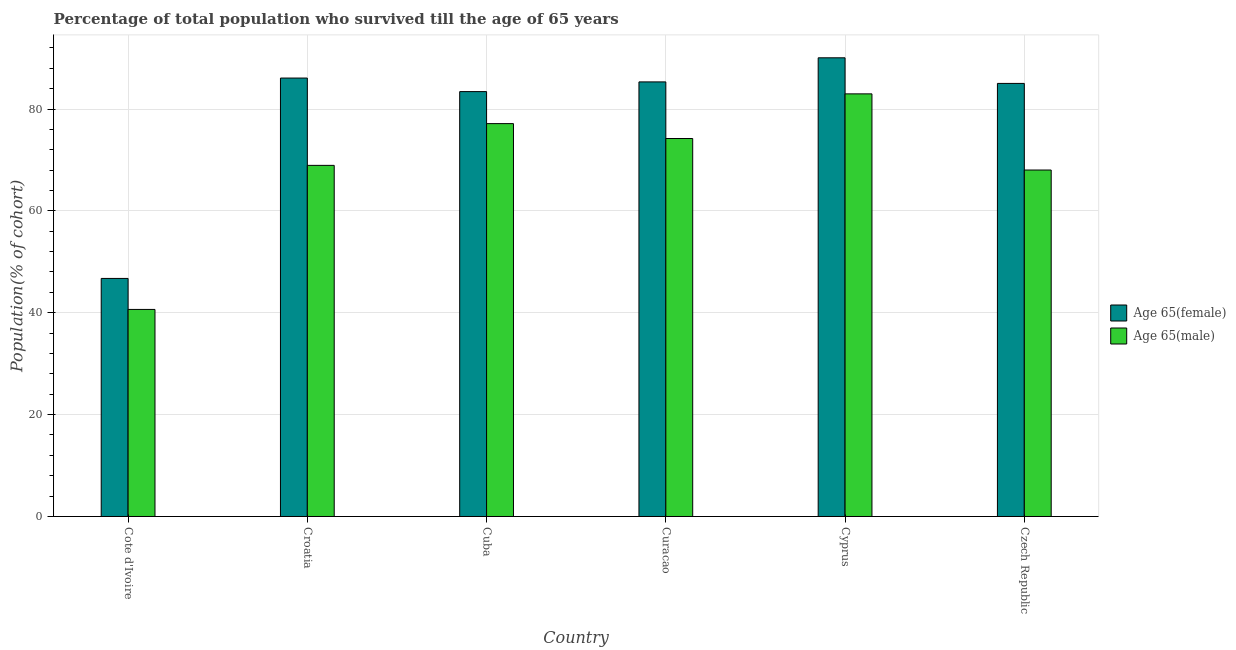How many different coloured bars are there?
Keep it short and to the point. 2. Are the number of bars on each tick of the X-axis equal?
Make the answer very short. Yes. How many bars are there on the 4th tick from the right?
Make the answer very short. 2. What is the label of the 4th group of bars from the left?
Make the answer very short. Curacao. What is the percentage of female population who survived till age of 65 in Curacao?
Offer a very short reply. 85.32. Across all countries, what is the maximum percentage of female population who survived till age of 65?
Give a very brief answer. 90.05. Across all countries, what is the minimum percentage of male population who survived till age of 65?
Your answer should be very brief. 40.65. In which country was the percentage of female population who survived till age of 65 maximum?
Make the answer very short. Cyprus. In which country was the percentage of female population who survived till age of 65 minimum?
Your answer should be compact. Cote d'Ivoire. What is the total percentage of male population who survived till age of 65 in the graph?
Make the answer very short. 411.92. What is the difference between the percentage of male population who survived till age of 65 in Croatia and that in Czech Republic?
Your answer should be compact. 0.91. What is the difference between the percentage of male population who survived till age of 65 in Cuba and the percentage of female population who survived till age of 65 in Cote d'Ivoire?
Make the answer very short. 30.39. What is the average percentage of male population who survived till age of 65 per country?
Your answer should be compact. 68.65. What is the difference between the percentage of male population who survived till age of 65 and percentage of female population who survived till age of 65 in Cuba?
Offer a terse response. -6.28. In how many countries, is the percentage of female population who survived till age of 65 greater than 44 %?
Your answer should be very brief. 6. What is the ratio of the percentage of male population who survived till age of 65 in Cuba to that in Czech Republic?
Give a very brief answer. 1.13. What is the difference between the highest and the second highest percentage of male population who survived till age of 65?
Make the answer very short. 5.84. What is the difference between the highest and the lowest percentage of male population who survived till age of 65?
Your answer should be compact. 42.32. Is the sum of the percentage of male population who survived till age of 65 in Curacao and Cyprus greater than the maximum percentage of female population who survived till age of 65 across all countries?
Your answer should be very brief. Yes. What does the 2nd bar from the left in Croatia represents?
Offer a very short reply. Age 65(male). What does the 2nd bar from the right in Cuba represents?
Your answer should be compact. Age 65(female). Are all the bars in the graph horizontal?
Make the answer very short. No. How many countries are there in the graph?
Your answer should be compact. 6. What is the difference between two consecutive major ticks on the Y-axis?
Offer a very short reply. 20. Does the graph contain grids?
Your response must be concise. Yes. How are the legend labels stacked?
Give a very brief answer. Vertical. What is the title of the graph?
Make the answer very short. Percentage of total population who survived till the age of 65 years. Does "Male" appear as one of the legend labels in the graph?
Provide a short and direct response. No. What is the label or title of the Y-axis?
Offer a terse response. Population(% of cohort). What is the Population(% of cohort) in Age 65(female) in Cote d'Ivoire?
Ensure brevity in your answer.  46.74. What is the Population(% of cohort) in Age 65(male) in Cote d'Ivoire?
Provide a succinct answer. 40.65. What is the Population(% of cohort) in Age 65(female) in Croatia?
Provide a short and direct response. 86.08. What is the Population(% of cohort) in Age 65(male) in Croatia?
Provide a succinct answer. 68.94. What is the Population(% of cohort) of Age 65(female) in Cuba?
Your answer should be very brief. 83.42. What is the Population(% of cohort) of Age 65(male) in Cuba?
Offer a terse response. 77.13. What is the Population(% of cohort) in Age 65(female) in Curacao?
Your answer should be compact. 85.32. What is the Population(% of cohort) of Age 65(male) in Curacao?
Ensure brevity in your answer.  74.21. What is the Population(% of cohort) of Age 65(female) in Cyprus?
Your answer should be compact. 90.05. What is the Population(% of cohort) of Age 65(male) in Cyprus?
Provide a succinct answer. 82.97. What is the Population(% of cohort) in Age 65(female) in Czech Republic?
Make the answer very short. 85.02. What is the Population(% of cohort) in Age 65(male) in Czech Republic?
Make the answer very short. 68.02. Across all countries, what is the maximum Population(% of cohort) of Age 65(female)?
Ensure brevity in your answer.  90.05. Across all countries, what is the maximum Population(% of cohort) in Age 65(male)?
Your answer should be very brief. 82.97. Across all countries, what is the minimum Population(% of cohort) of Age 65(female)?
Keep it short and to the point. 46.74. Across all countries, what is the minimum Population(% of cohort) in Age 65(male)?
Offer a terse response. 40.65. What is the total Population(% of cohort) of Age 65(female) in the graph?
Your answer should be compact. 476.63. What is the total Population(% of cohort) of Age 65(male) in the graph?
Keep it short and to the point. 411.92. What is the difference between the Population(% of cohort) of Age 65(female) in Cote d'Ivoire and that in Croatia?
Make the answer very short. -39.34. What is the difference between the Population(% of cohort) in Age 65(male) in Cote d'Ivoire and that in Croatia?
Your answer should be compact. -28.29. What is the difference between the Population(% of cohort) in Age 65(female) in Cote d'Ivoire and that in Cuba?
Your answer should be very brief. -36.68. What is the difference between the Population(% of cohort) in Age 65(male) in Cote d'Ivoire and that in Cuba?
Ensure brevity in your answer.  -36.48. What is the difference between the Population(% of cohort) in Age 65(female) in Cote d'Ivoire and that in Curacao?
Make the answer very short. -38.58. What is the difference between the Population(% of cohort) of Age 65(male) in Cote d'Ivoire and that in Curacao?
Your answer should be compact. -33.56. What is the difference between the Population(% of cohort) of Age 65(female) in Cote d'Ivoire and that in Cyprus?
Your answer should be compact. -43.31. What is the difference between the Population(% of cohort) in Age 65(male) in Cote d'Ivoire and that in Cyprus?
Keep it short and to the point. -42.32. What is the difference between the Population(% of cohort) in Age 65(female) in Cote d'Ivoire and that in Czech Republic?
Offer a very short reply. -38.28. What is the difference between the Population(% of cohort) in Age 65(male) in Cote d'Ivoire and that in Czech Republic?
Give a very brief answer. -27.37. What is the difference between the Population(% of cohort) of Age 65(female) in Croatia and that in Cuba?
Offer a terse response. 2.66. What is the difference between the Population(% of cohort) in Age 65(male) in Croatia and that in Cuba?
Provide a succinct answer. -8.2. What is the difference between the Population(% of cohort) in Age 65(female) in Croatia and that in Curacao?
Ensure brevity in your answer.  0.76. What is the difference between the Population(% of cohort) of Age 65(male) in Croatia and that in Curacao?
Provide a short and direct response. -5.27. What is the difference between the Population(% of cohort) in Age 65(female) in Croatia and that in Cyprus?
Your response must be concise. -3.97. What is the difference between the Population(% of cohort) in Age 65(male) in Croatia and that in Cyprus?
Keep it short and to the point. -14.04. What is the difference between the Population(% of cohort) of Age 65(female) in Croatia and that in Czech Republic?
Offer a terse response. 1.05. What is the difference between the Population(% of cohort) of Age 65(male) in Croatia and that in Czech Republic?
Provide a short and direct response. 0.91. What is the difference between the Population(% of cohort) of Age 65(female) in Cuba and that in Curacao?
Keep it short and to the point. -1.91. What is the difference between the Population(% of cohort) in Age 65(male) in Cuba and that in Curacao?
Give a very brief answer. 2.93. What is the difference between the Population(% of cohort) of Age 65(female) in Cuba and that in Cyprus?
Your answer should be compact. -6.64. What is the difference between the Population(% of cohort) in Age 65(male) in Cuba and that in Cyprus?
Provide a succinct answer. -5.84. What is the difference between the Population(% of cohort) of Age 65(female) in Cuba and that in Czech Republic?
Provide a succinct answer. -1.61. What is the difference between the Population(% of cohort) of Age 65(male) in Cuba and that in Czech Republic?
Offer a terse response. 9.11. What is the difference between the Population(% of cohort) of Age 65(female) in Curacao and that in Cyprus?
Make the answer very short. -4.73. What is the difference between the Population(% of cohort) of Age 65(male) in Curacao and that in Cyprus?
Your answer should be very brief. -8.76. What is the difference between the Population(% of cohort) in Age 65(female) in Curacao and that in Czech Republic?
Provide a short and direct response. 0.3. What is the difference between the Population(% of cohort) in Age 65(male) in Curacao and that in Czech Republic?
Offer a terse response. 6.19. What is the difference between the Population(% of cohort) of Age 65(female) in Cyprus and that in Czech Republic?
Offer a terse response. 5.03. What is the difference between the Population(% of cohort) of Age 65(male) in Cyprus and that in Czech Republic?
Ensure brevity in your answer.  14.95. What is the difference between the Population(% of cohort) in Age 65(female) in Cote d'Ivoire and the Population(% of cohort) in Age 65(male) in Croatia?
Offer a very short reply. -22.2. What is the difference between the Population(% of cohort) in Age 65(female) in Cote d'Ivoire and the Population(% of cohort) in Age 65(male) in Cuba?
Provide a short and direct response. -30.39. What is the difference between the Population(% of cohort) of Age 65(female) in Cote d'Ivoire and the Population(% of cohort) of Age 65(male) in Curacao?
Give a very brief answer. -27.47. What is the difference between the Population(% of cohort) of Age 65(female) in Cote d'Ivoire and the Population(% of cohort) of Age 65(male) in Cyprus?
Give a very brief answer. -36.23. What is the difference between the Population(% of cohort) in Age 65(female) in Cote d'Ivoire and the Population(% of cohort) in Age 65(male) in Czech Republic?
Give a very brief answer. -21.28. What is the difference between the Population(% of cohort) of Age 65(female) in Croatia and the Population(% of cohort) of Age 65(male) in Cuba?
Ensure brevity in your answer.  8.95. What is the difference between the Population(% of cohort) of Age 65(female) in Croatia and the Population(% of cohort) of Age 65(male) in Curacao?
Make the answer very short. 11.87. What is the difference between the Population(% of cohort) in Age 65(female) in Croatia and the Population(% of cohort) in Age 65(male) in Cyprus?
Your answer should be compact. 3.11. What is the difference between the Population(% of cohort) in Age 65(female) in Croatia and the Population(% of cohort) in Age 65(male) in Czech Republic?
Make the answer very short. 18.06. What is the difference between the Population(% of cohort) in Age 65(female) in Cuba and the Population(% of cohort) in Age 65(male) in Curacao?
Your response must be concise. 9.21. What is the difference between the Population(% of cohort) of Age 65(female) in Cuba and the Population(% of cohort) of Age 65(male) in Cyprus?
Provide a succinct answer. 0.45. What is the difference between the Population(% of cohort) in Age 65(female) in Cuba and the Population(% of cohort) in Age 65(male) in Czech Republic?
Ensure brevity in your answer.  15.4. What is the difference between the Population(% of cohort) in Age 65(female) in Curacao and the Population(% of cohort) in Age 65(male) in Cyprus?
Ensure brevity in your answer.  2.35. What is the difference between the Population(% of cohort) in Age 65(female) in Curacao and the Population(% of cohort) in Age 65(male) in Czech Republic?
Provide a succinct answer. 17.3. What is the difference between the Population(% of cohort) of Age 65(female) in Cyprus and the Population(% of cohort) of Age 65(male) in Czech Republic?
Provide a short and direct response. 22.03. What is the average Population(% of cohort) of Age 65(female) per country?
Your answer should be very brief. 79.44. What is the average Population(% of cohort) of Age 65(male) per country?
Your answer should be compact. 68.65. What is the difference between the Population(% of cohort) in Age 65(female) and Population(% of cohort) in Age 65(male) in Cote d'Ivoire?
Your answer should be compact. 6.09. What is the difference between the Population(% of cohort) of Age 65(female) and Population(% of cohort) of Age 65(male) in Croatia?
Keep it short and to the point. 17.14. What is the difference between the Population(% of cohort) of Age 65(female) and Population(% of cohort) of Age 65(male) in Cuba?
Ensure brevity in your answer.  6.28. What is the difference between the Population(% of cohort) in Age 65(female) and Population(% of cohort) in Age 65(male) in Curacao?
Make the answer very short. 11.11. What is the difference between the Population(% of cohort) in Age 65(female) and Population(% of cohort) in Age 65(male) in Cyprus?
Offer a very short reply. 7.08. What is the difference between the Population(% of cohort) of Age 65(female) and Population(% of cohort) of Age 65(male) in Czech Republic?
Provide a succinct answer. 17. What is the ratio of the Population(% of cohort) of Age 65(female) in Cote d'Ivoire to that in Croatia?
Your response must be concise. 0.54. What is the ratio of the Population(% of cohort) in Age 65(male) in Cote d'Ivoire to that in Croatia?
Offer a very short reply. 0.59. What is the ratio of the Population(% of cohort) of Age 65(female) in Cote d'Ivoire to that in Cuba?
Provide a succinct answer. 0.56. What is the ratio of the Population(% of cohort) of Age 65(male) in Cote d'Ivoire to that in Cuba?
Ensure brevity in your answer.  0.53. What is the ratio of the Population(% of cohort) of Age 65(female) in Cote d'Ivoire to that in Curacao?
Offer a very short reply. 0.55. What is the ratio of the Population(% of cohort) of Age 65(male) in Cote d'Ivoire to that in Curacao?
Offer a terse response. 0.55. What is the ratio of the Population(% of cohort) of Age 65(female) in Cote d'Ivoire to that in Cyprus?
Your answer should be compact. 0.52. What is the ratio of the Population(% of cohort) of Age 65(male) in Cote d'Ivoire to that in Cyprus?
Your response must be concise. 0.49. What is the ratio of the Population(% of cohort) in Age 65(female) in Cote d'Ivoire to that in Czech Republic?
Give a very brief answer. 0.55. What is the ratio of the Population(% of cohort) in Age 65(male) in Cote d'Ivoire to that in Czech Republic?
Keep it short and to the point. 0.6. What is the ratio of the Population(% of cohort) in Age 65(female) in Croatia to that in Cuba?
Provide a succinct answer. 1.03. What is the ratio of the Population(% of cohort) of Age 65(male) in Croatia to that in Cuba?
Give a very brief answer. 0.89. What is the ratio of the Population(% of cohort) in Age 65(female) in Croatia to that in Curacao?
Offer a terse response. 1.01. What is the ratio of the Population(% of cohort) in Age 65(male) in Croatia to that in Curacao?
Ensure brevity in your answer.  0.93. What is the ratio of the Population(% of cohort) in Age 65(female) in Croatia to that in Cyprus?
Make the answer very short. 0.96. What is the ratio of the Population(% of cohort) of Age 65(male) in Croatia to that in Cyprus?
Ensure brevity in your answer.  0.83. What is the ratio of the Population(% of cohort) in Age 65(female) in Croatia to that in Czech Republic?
Your answer should be very brief. 1.01. What is the ratio of the Population(% of cohort) of Age 65(male) in Croatia to that in Czech Republic?
Offer a terse response. 1.01. What is the ratio of the Population(% of cohort) of Age 65(female) in Cuba to that in Curacao?
Provide a short and direct response. 0.98. What is the ratio of the Population(% of cohort) in Age 65(male) in Cuba to that in Curacao?
Offer a very short reply. 1.04. What is the ratio of the Population(% of cohort) of Age 65(female) in Cuba to that in Cyprus?
Provide a short and direct response. 0.93. What is the ratio of the Population(% of cohort) in Age 65(male) in Cuba to that in Cyprus?
Offer a terse response. 0.93. What is the ratio of the Population(% of cohort) in Age 65(female) in Cuba to that in Czech Republic?
Your answer should be compact. 0.98. What is the ratio of the Population(% of cohort) of Age 65(male) in Cuba to that in Czech Republic?
Your response must be concise. 1.13. What is the ratio of the Population(% of cohort) of Age 65(female) in Curacao to that in Cyprus?
Give a very brief answer. 0.95. What is the ratio of the Population(% of cohort) of Age 65(male) in Curacao to that in Cyprus?
Ensure brevity in your answer.  0.89. What is the ratio of the Population(% of cohort) of Age 65(male) in Curacao to that in Czech Republic?
Your answer should be compact. 1.09. What is the ratio of the Population(% of cohort) of Age 65(female) in Cyprus to that in Czech Republic?
Your answer should be very brief. 1.06. What is the ratio of the Population(% of cohort) in Age 65(male) in Cyprus to that in Czech Republic?
Your answer should be compact. 1.22. What is the difference between the highest and the second highest Population(% of cohort) in Age 65(female)?
Provide a succinct answer. 3.97. What is the difference between the highest and the second highest Population(% of cohort) of Age 65(male)?
Give a very brief answer. 5.84. What is the difference between the highest and the lowest Population(% of cohort) of Age 65(female)?
Offer a very short reply. 43.31. What is the difference between the highest and the lowest Population(% of cohort) in Age 65(male)?
Provide a succinct answer. 42.32. 